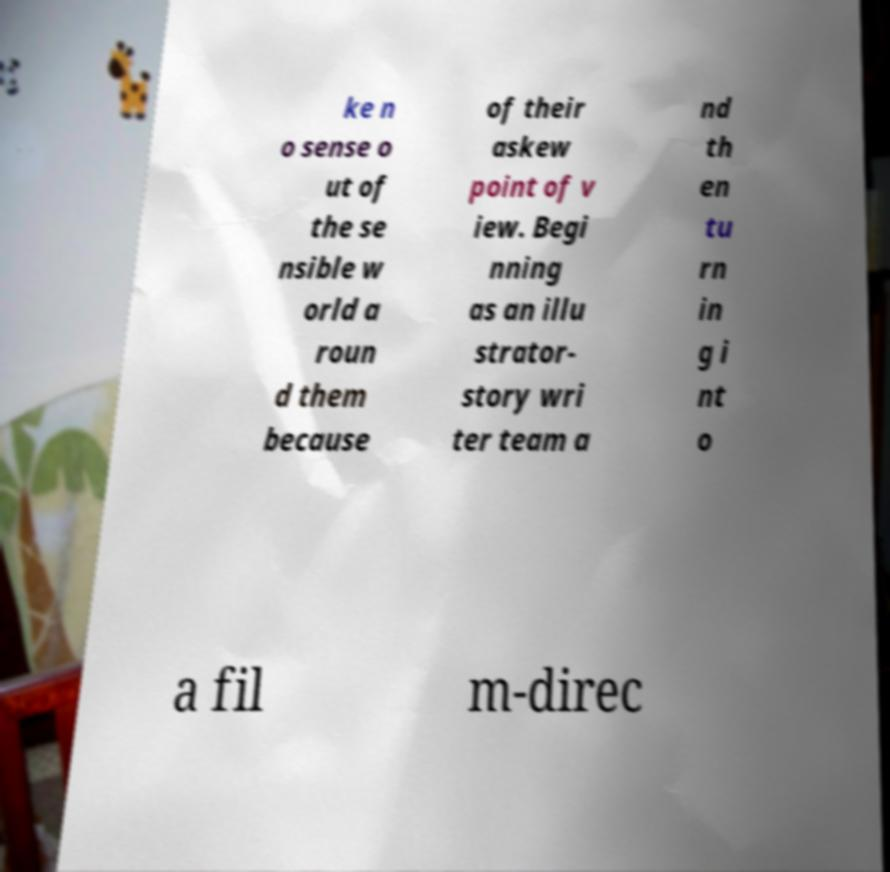What messages or text are displayed in this image? I need them in a readable, typed format. ke n o sense o ut of the se nsible w orld a roun d them because of their askew point of v iew. Begi nning as an illu strator- story wri ter team a nd th en tu rn in g i nt o a fil m-direc 